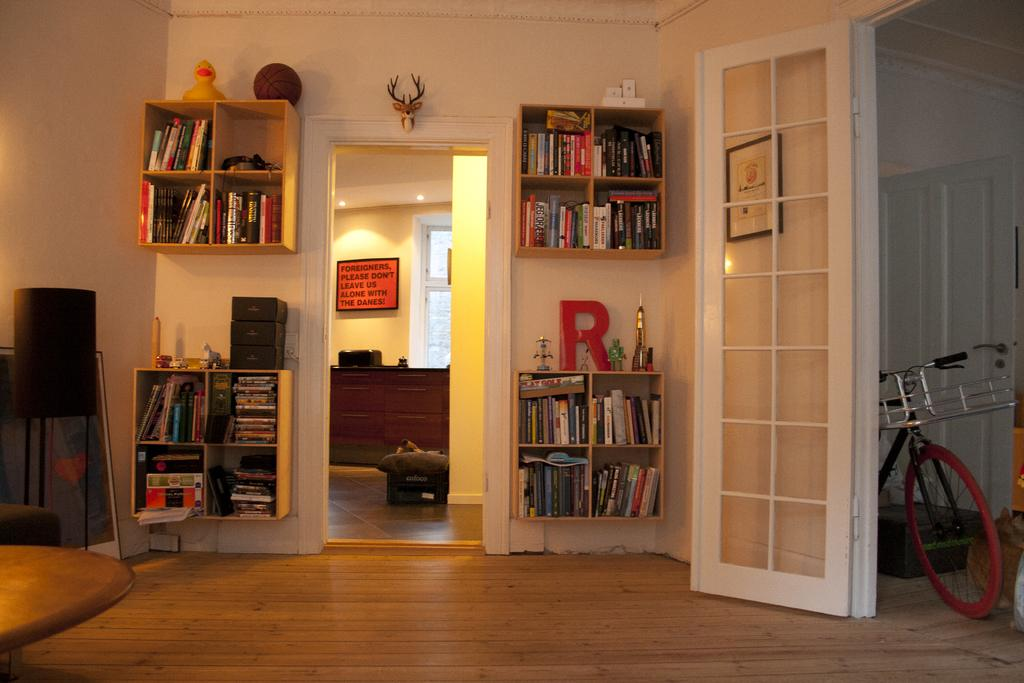<image>
Offer a succinct explanation of the picture presented. A sign that says Please don't leave us alone with the Danes hangs in a home. 